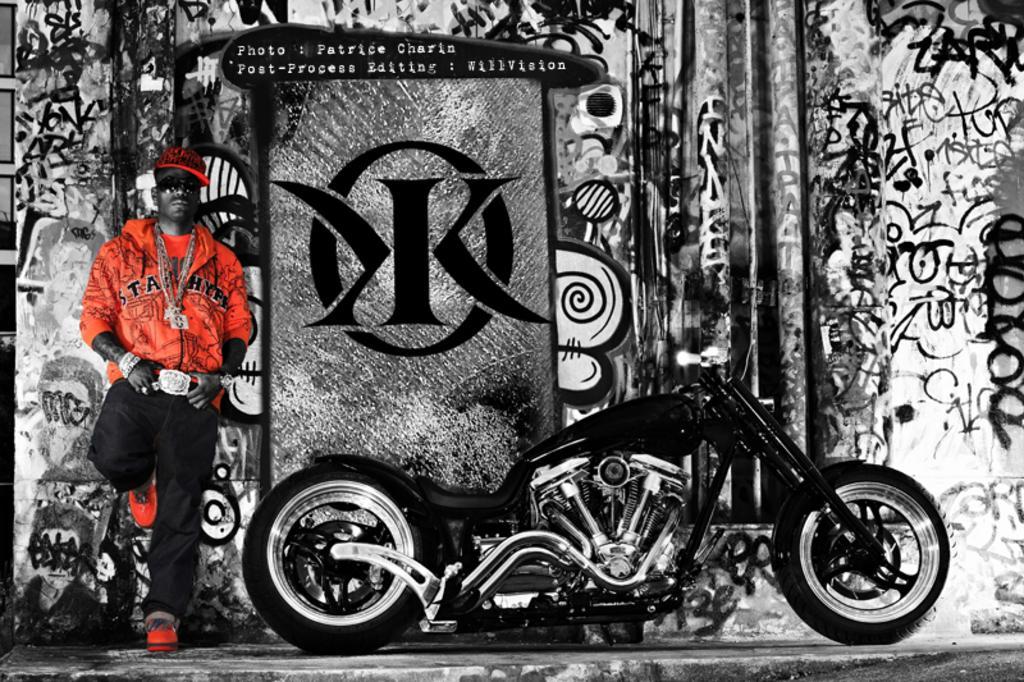Describe this image in one or two sentences. In the image we can see there is a person standing and he is wearing red colour jacket. Beside him there is a bike kept on the ground and there is graffiti done on the wall. The image is in black and white colour. 